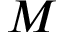Convert formula to latex. <formula><loc_0><loc_0><loc_500><loc_500>M</formula> 